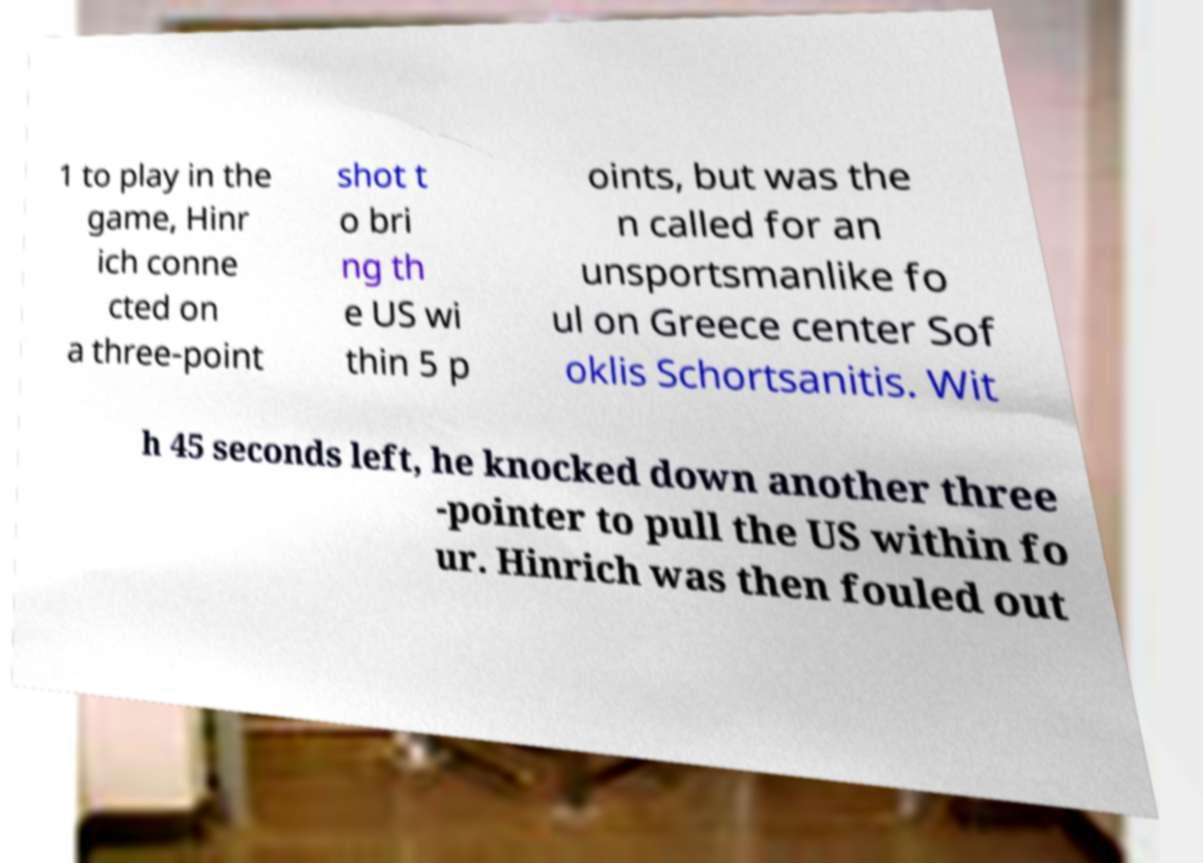Could you assist in decoding the text presented in this image and type it out clearly? 1 to play in the game, Hinr ich conne cted on a three-point shot t o bri ng th e US wi thin 5 p oints, but was the n called for an unsportsmanlike fo ul on Greece center Sof oklis Schortsanitis. Wit h 45 seconds left, he knocked down another three -pointer to pull the US within fo ur. Hinrich was then fouled out 